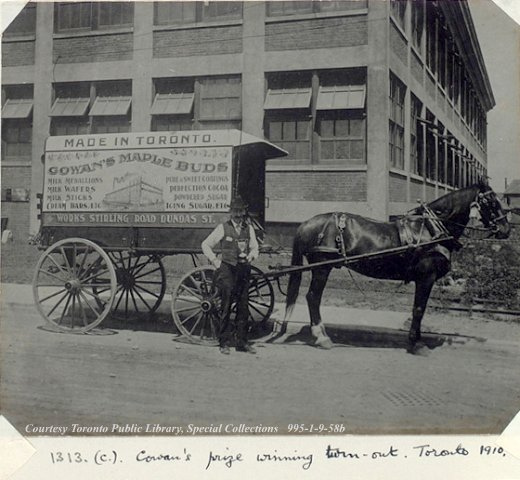Identify the text contained in this image. MADE IN TORONTO ROAD 1910. OUT winning C 1313 995 Collections Special Library Public Toronto COURTESY BUDS GOWAN'S 